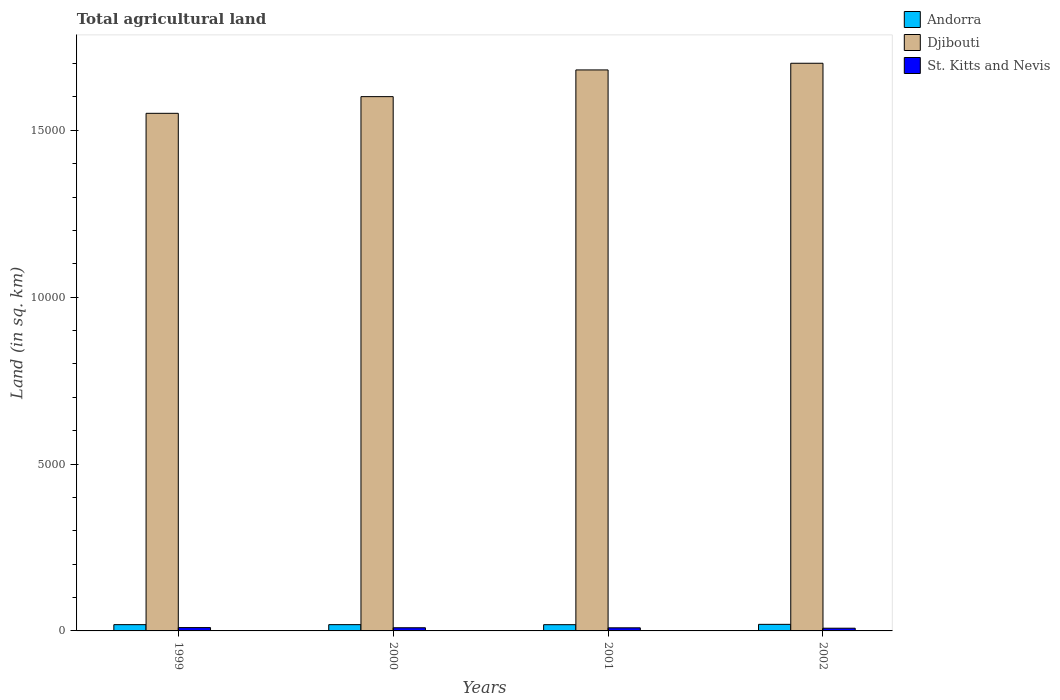How many different coloured bars are there?
Ensure brevity in your answer.  3. How many groups of bars are there?
Provide a succinct answer. 4. Are the number of bars on each tick of the X-axis equal?
Ensure brevity in your answer.  Yes. How many bars are there on the 3rd tick from the right?
Ensure brevity in your answer.  3. What is the label of the 4th group of bars from the left?
Offer a terse response. 2002. In how many cases, is the number of bars for a given year not equal to the number of legend labels?
Offer a very short reply. 0. What is the total agricultural land in St. Kitts and Nevis in 2002?
Your answer should be compact. 81. Across all years, what is the maximum total agricultural land in St. Kitts and Nevis?
Your response must be concise. 100. In which year was the total agricultural land in Djibouti minimum?
Your answer should be very brief. 1999. What is the total total agricultural land in St. Kitts and Nevis in the graph?
Ensure brevity in your answer.  369. What is the difference between the total agricultural land in St. Kitts and Nevis in 1999 and that in 2001?
Your answer should be compact. 7. What is the difference between the total agricultural land in Andorra in 2002 and the total agricultural land in St. Kitts and Nevis in 1999?
Your answer should be very brief. 97. What is the average total agricultural land in Andorra per year?
Make the answer very short. 190. In the year 2002, what is the difference between the total agricultural land in St. Kitts and Nevis and total agricultural land in Djibouti?
Provide a succinct answer. -1.69e+04. What is the ratio of the total agricultural land in Djibouti in 1999 to that in 2001?
Provide a short and direct response. 0.92. Is the total agricultural land in Andorra in 2000 less than that in 2002?
Keep it short and to the point. Yes. Is the difference between the total agricultural land in St. Kitts and Nevis in 2001 and 2002 greater than the difference between the total agricultural land in Djibouti in 2001 and 2002?
Offer a very short reply. Yes. What is the difference between the highest and the second highest total agricultural land in St. Kitts and Nevis?
Give a very brief answer. 5. What is the difference between the highest and the lowest total agricultural land in St. Kitts and Nevis?
Ensure brevity in your answer.  19. In how many years, is the total agricultural land in St. Kitts and Nevis greater than the average total agricultural land in St. Kitts and Nevis taken over all years?
Offer a very short reply. 3. What does the 1st bar from the left in 2001 represents?
Offer a terse response. Andorra. What does the 3rd bar from the right in 1999 represents?
Make the answer very short. Andorra. How many bars are there?
Offer a very short reply. 12. Are all the bars in the graph horizontal?
Keep it short and to the point. No. What is the difference between two consecutive major ticks on the Y-axis?
Your response must be concise. 5000. Where does the legend appear in the graph?
Your answer should be very brief. Top right. What is the title of the graph?
Provide a short and direct response. Total agricultural land. Does "New Zealand" appear as one of the legend labels in the graph?
Your answer should be very brief. No. What is the label or title of the Y-axis?
Ensure brevity in your answer.  Land (in sq. km). What is the Land (in sq. km) in Andorra in 1999?
Your response must be concise. 188. What is the Land (in sq. km) of Djibouti in 1999?
Give a very brief answer. 1.55e+04. What is the Land (in sq. km) in Andorra in 2000?
Your answer should be very brief. 188. What is the Land (in sq. km) in Djibouti in 2000?
Make the answer very short. 1.60e+04. What is the Land (in sq. km) in St. Kitts and Nevis in 2000?
Provide a short and direct response. 95. What is the Land (in sq. km) of Andorra in 2001?
Make the answer very short. 187. What is the Land (in sq. km) of Djibouti in 2001?
Your answer should be compact. 1.68e+04. What is the Land (in sq. km) in St. Kitts and Nevis in 2001?
Ensure brevity in your answer.  93. What is the Land (in sq. km) of Andorra in 2002?
Your answer should be very brief. 197. What is the Land (in sq. km) of Djibouti in 2002?
Make the answer very short. 1.70e+04. What is the Land (in sq. km) in St. Kitts and Nevis in 2002?
Offer a terse response. 81. Across all years, what is the maximum Land (in sq. km) in Andorra?
Your answer should be very brief. 197. Across all years, what is the maximum Land (in sq. km) of Djibouti?
Your answer should be very brief. 1.70e+04. Across all years, what is the maximum Land (in sq. km) in St. Kitts and Nevis?
Keep it short and to the point. 100. Across all years, what is the minimum Land (in sq. km) in Andorra?
Provide a short and direct response. 187. Across all years, what is the minimum Land (in sq. km) in Djibouti?
Provide a succinct answer. 1.55e+04. Across all years, what is the minimum Land (in sq. km) of St. Kitts and Nevis?
Offer a very short reply. 81. What is the total Land (in sq. km) of Andorra in the graph?
Offer a terse response. 760. What is the total Land (in sq. km) in Djibouti in the graph?
Provide a short and direct response. 6.53e+04. What is the total Land (in sq. km) of St. Kitts and Nevis in the graph?
Provide a succinct answer. 369. What is the difference between the Land (in sq. km) in Djibouti in 1999 and that in 2000?
Ensure brevity in your answer.  -500. What is the difference between the Land (in sq. km) in St. Kitts and Nevis in 1999 and that in 2000?
Your answer should be very brief. 5. What is the difference between the Land (in sq. km) in Djibouti in 1999 and that in 2001?
Offer a terse response. -1300. What is the difference between the Land (in sq. km) in St. Kitts and Nevis in 1999 and that in 2001?
Ensure brevity in your answer.  7. What is the difference between the Land (in sq. km) in Andorra in 1999 and that in 2002?
Give a very brief answer. -9. What is the difference between the Land (in sq. km) of Djibouti in 1999 and that in 2002?
Your response must be concise. -1500. What is the difference between the Land (in sq. km) of Andorra in 2000 and that in 2001?
Offer a terse response. 1. What is the difference between the Land (in sq. km) in Djibouti in 2000 and that in 2001?
Your response must be concise. -800. What is the difference between the Land (in sq. km) in St. Kitts and Nevis in 2000 and that in 2001?
Provide a succinct answer. 2. What is the difference between the Land (in sq. km) in Djibouti in 2000 and that in 2002?
Provide a succinct answer. -1000. What is the difference between the Land (in sq. km) of St. Kitts and Nevis in 2000 and that in 2002?
Offer a terse response. 14. What is the difference between the Land (in sq. km) in Andorra in 2001 and that in 2002?
Give a very brief answer. -10. What is the difference between the Land (in sq. km) in Djibouti in 2001 and that in 2002?
Give a very brief answer. -200. What is the difference between the Land (in sq. km) of Andorra in 1999 and the Land (in sq. km) of Djibouti in 2000?
Offer a very short reply. -1.58e+04. What is the difference between the Land (in sq. km) of Andorra in 1999 and the Land (in sq. km) of St. Kitts and Nevis in 2000?
Your answer should be compact. 93. What is the difference between the Land (in sq. km) in Djibouti in 1999 and the Land (in sq. km) in St. Kitts and Nevis in 2000?
Your answer should be very brief. 1.54e+04. What is the difference between the Land (in sq. km) of Andorra in 1999 and the Land (in sq. km) of Djibouti in 2001?
Offer a terse response. -1.66e+04. What is the difference between the Land (in sq. km) of Andorra in 1999 and the Land (in sq. km) of St. Kitts and Nevis in 2001?
Ensure brevity in your answer.  95. What is the difference between the Land (in sq. km) in Djibouti in 1999 and the Land (in sq. km) in St. Kitts and Nevis in 2001?
Provide a short and direct response. 1.54e+04. What is the difference between the Land (in sq. km) in Andorra in 1999 and the Land (in sq. km) in Djibouti in 2002?
Provide a succinct answer. -1.68e+04. What is the difference between the Land (in sq. km) in Andorra in 1999 and the Land (in sq. km) in St. Kitts and Nevis in 2002?
Offer a terse response. 107. What is the difference between the Land (in sq. km) of Djibouti in 1999 and the Land (in sq. km) of St. Kitts and Nevis in 2002?
Provide a succinct answer. 1.54e+04. What is the difference between the Land (in sq. km) of Andorra in 2000 and the Land (in sq. km) of Djibouti in 2001?
Keep it short and to the point. -1.66e+04. What is the difference between the Land (in sq. km) of Djibouti in 2000 and the Land (in sq. km) of St. Kitts and Nevis in 2001?
Provide a short and direct response. 1.59e+04. What is the difference between the Land (in sq. km) of Andorra in 2000 and the Land (in sq. km) of Djibouti in 2002?
Provide a succinct answer. -1.68e+04. What is the difference between the Land (in sq. km) in Andorra in 2000 and the Land (in sq. km) in St. Kitts and Nevis in 2002?
Keep it short and to the point. 107. What is the difference between the Land (in sq. km) of Djibouti in 2000 and the Land (in sq. km) of St. Kitts and Nevis in 2002?
Provide a succinct answer. 1.59e+04. What is the difference between the Land (in sq. km) of Andorra in 2001 and the Land (in sq. km) of Djibouti in 2002?
Give a very brief answer. -1.68e+04. What is the difference between the Land (in sq. km) of Andorra in 2001 and the Land (in sq. km) of St. Kitts and Nevis in 2002?
Give a very brief answer. 106. What is the difference between the Land (in sq. km) in Djibouti in 2001 and the Land (in sq. km) in St. Kitts and Nevis in 2002?
Make the answer very short. 1.67e+04. What is the average Land (in sq. km) in Andorra per year?
Give a very brief answer. 190. What is the average Land (in sq. km) of Djibouti per year?
Provide a succinct answer. 1.63e+04. What is the average Land (in sq. km) of St. Kitts and Nevis per year?
Give a very brief answer. 92.25. In the year 1999, what is the difference between the Land (in sq. km) of Andorra and Land (in sq. km) of Djibouti?
Offer a very short reply. -1.53e+04. In the year 1999, what is the difference between the Land (in sq. km) of Djibouti and Land (in sq. km) of St. Kitts and Nevis?
Ensure brevity in your answer.  1.54e+04. In the year 2000, what is the difference between the Land (in sq. km) of Andorra and Land (in sq. km) of Djibouti?
Provide a succinct answer. -1.58e+04. In the year 2000, what is the difference between the Land (in sq. km) of Andorra and Land (in sq. km) of St. Kitts and Nevis?
Make the answer very short. 93. In the year 2000, what is the difference between the Land (in sq. km) of Djibouti and Land (in sq. km) of St. Kitts and Nevis?
Offer a very short reply. 1.59e+04. In the year 2001, what is the difference between the Land (in sq. km) of Andorra and Land (in sq. km) of Djibouti?
Your answer should be very brief. -1.66e+04. In the year 2001, what is the difference between the Land (in sq. km) of Andorra and Land (in sq. km) of St. Kitts and Nevis?
Offer a very short reply. 94. In the year 2001, what is the difference between the Land (in sq. km) of Djibouti and Land (in sq. km) of St. Kitts and Nevis?
Provide a succinct answer. 1.67e+04. In the year 2002, what is the difference between the Land (in sq. km) in Andorra and Land (in sq. km) in Djibouti?
Provide a succinct answer. -1.68e+04. In the year 2002, what is the difference between the Land (in sq. km) in Andorra and Land (in sq. km) in St. Kitts and Nevis?
Provide a short and direct response. 116. In the year 2002, what is the difference between the Land (in sq. km) in Djibouti and Land (in sq. km) in St. Kitts and Nevis?
Keep it short and to the point. 1.69e+04. What is the ratio of the Land (in sq. km) in Djibouti in 1999 to that in 2000?
Offer a very short reply. 0.97. What is the ratio of the Land (in sq. km) in St. Kitts and Nevis in 1999 to that in 2000?
Offer a very short reply. 1.05. What is the ratio of the Land (in sq. km) in Andorra in 1999 to that in 2001?
Ensure brevity in your answer.  1.01. What is the ratio of the Land (in sq. km) in Djibouti in 1999 to that in 2001?
Provide a succinct answer. 0.92. What is the ratio of the Land (in sq. km) of St. Kitts and Nevis in 1999 to that in 2001?
Your answer should be very brief. 1.08. What is the ratio of the Land (in sq. km) of Andorra in 1999 to that in 2002?
Offer a very short reply. 0.95. What is the ratio of the Land (in sq. km) in Djibouti in 1999 to that in 2002?
Your response must be concise. 0.91. What is the ratio of the Land (in sq. km) in St. Kitts and Nevis in 1999 to that in 2002?
Ensure brevity in your answer.  1.23. What is the ratio of the Land (in sq. km) of St. Kitts and Nevis in 2000 to that in 2001?
Your answer should be very brief. 1.02. What is the ratio of the Land (in sq. km) of Andorra in 2000 to that in 2002?
Your answer should be very brief. 0.95. What is the ratio of the Land (in sq. km) in St. Kitts and Nevis in 2000 to that in 2002?
Offer a very short reply. 1.17. What is the ratio of the Land (in sq. km) in Andorra in 2001 to that in 2002?
Provide a succinct answer. 0.95. What is the ratio of the Land (in sq. km) of St. Kitts and Nevis in 2001 to that in 2002?
Keep it short and to the point. 1.15. What is the difference between the highest and the second highest Land (in sq. km) in Andorra?
Make the answer very short. 9. What is the difference between the highest and the second highest Land (in sq. km) in St. Kitts and Nevis?
Give a very brief answer. 5. What is the difference between the highest and the lowest Land (in sq. km) of Djibouti?
Offer a terse response. 1500. What is the difference between the highest and the lowest Land (in sq. km) of St. Kitts and Nevis?
Offer a very short reply. 19. 